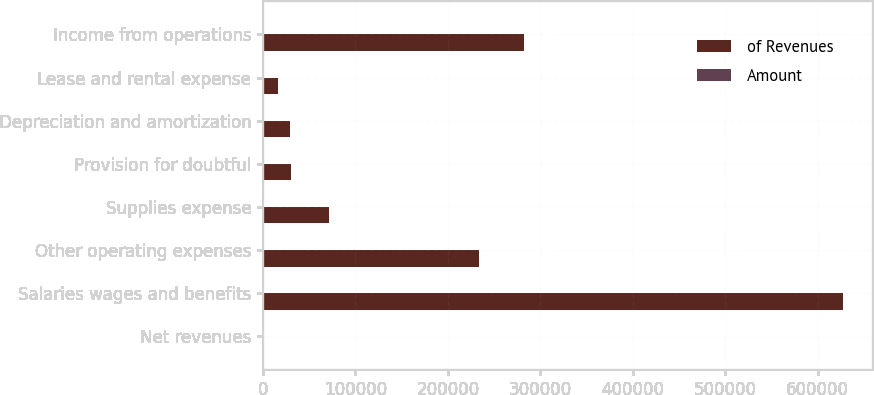Convert chart. <chart><loc_0><loc_0><loc_500><loc_500><stacked_bar_chart><ecel><fcel>Net revenues<fcel>Salaries wages and benefits<fcel>Other operating expenses<fcel>Supplies expense<fcel>Provision for doubtful<fcel>Depreciation and amortization<fcel>Lease and rental expense<fcel>Income from operations<nl><fcel>of Revenues<fcel>100<fcel>627683<fcel>233452<fcel>71891<fcel>30558<fcel>29556<fcel>15837<fcel>282633<nl><fcel>Amount<fcel>100<fcel>48.6<fcel>18.1<fcel>5.6<fcel>2.4<fcel>2.3<fcel>1.2<fcel>21.9<nl></chart> 